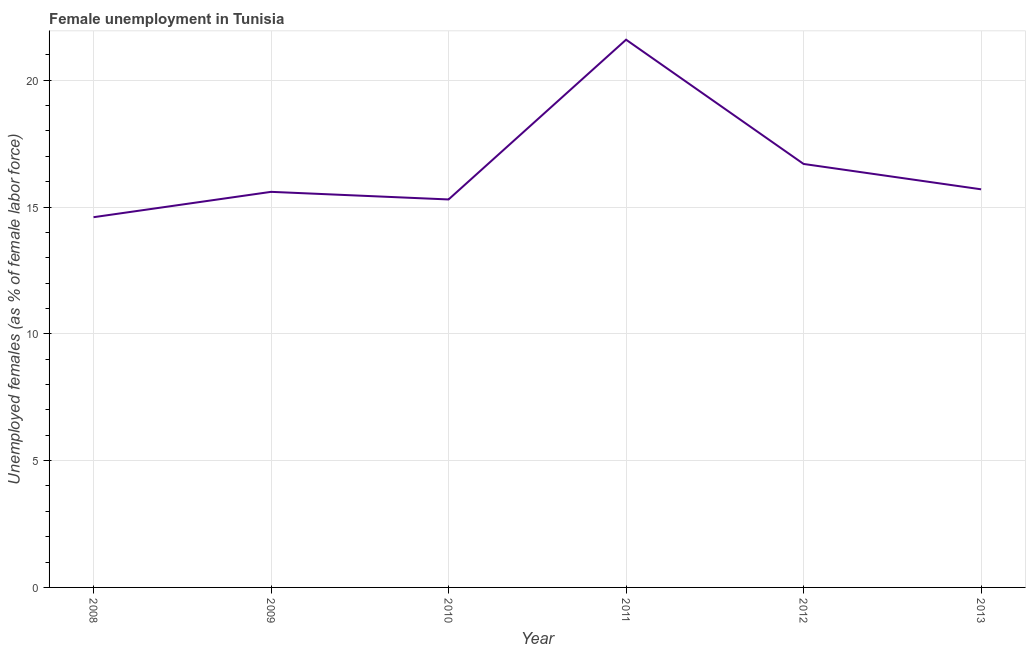What is the unemployed females population in 2013?
Ensure brevity in your answer.  15.7. Across all years, what is the maximum unemployed females population?
Provide a short and direct response. 21.6. Across all years, what is the minimum unemployed females population?
Your answer should be very brief. 14.6. In which year was the unemployed females population minimum?
Keep it short and to the point. 2008. What is the sum of the unemployed females population?
Make the answer very short. 99.5. What is the difference between the unemployed females population in 2008 and 2011?
Ensure brevity in your answer.  -7. What is the average unemployed females population per year?
Provide a short and direct response. 16.58. What is the median unemployed females population?
Ensure brevity in your answer.  15.65. In how many years, is the unemployed females population greater than 13 %?
Make the answer very short. 6. Do a majority of the years between 2009 and 2010 (inclusive) have unemployed females population greater than 20 %?
Ensure brevity in your answer.  No. What is the ratio of the unemployed females population in 2010 to that in 2011?
Provide a short and direct response. 0.71. Is the difference between the unemployed females population in 2008 and 2010 greater than the difference between any two years?
Your response must be concise. No. What is the difference between the highest and the second highest unemployed females population?
Provide a short and direct response. 4.9. What is the difference between the highest and the lowest unemployed females population?
Ensure brevity in your answer.  7. In how many years, is the unemployed females population greater than the average unemployed females population taken over all years?
Your answer should be very brief. 2. Does the unemployed females population monotonically increase over the years?
Make the answer very short. No. How many lines are there?
Provide a short and direct response. 1. How many years are there in the graph?
Keep it short and to the point. 6. Are the values on the major ticks of Y-axis written in scientific E-notation?
Your answer should be very brief. No. Does the graph contain any zero values?
Ensure brevity in your answer.  No. What is the title of the graph?
Provide a short and direct response. Female unemployment in Tunisia. What is the label or title of the Y-axis?
Offer a very short reply. Unemployed females (as % of female labor force). What is the Unemployed females (as % of female labor force) of 2008?
Your answer should be very brief. 14.6. What is the Unemployed females (as % of female labor force) in 2009?
Ensure brevity in your answer.  15.6. What is the Unemployed females (as % of female labor force) of 2010?
Provide a succinct answer. 15.3. What is the Unemployed females (as % of female labor force) in 2011?
Provide a short and direct response. 21.6. What is the Unemployed females (as % of female labor force) in 2012?
Provide a short and direct response. 16.7. What is the Unemployed females (as % of female labor force) in 2013?
Provide a short and direct response. 15.7. What is the difference between the Unemployed females (as % of female labor force) in 2008 and 2012?
Give a very brief answer. -2.1. What is the difference between the Unemployed females (as % of female labor force) in 2009 and 2010?
Ensure brevity in your answer.  0.3. What is the difference between the Unemployed females (as % of female labor force) in 2009 and 2011?
Provide a succinct answer. -6. What is the difference between the Unemployed females (as % of female labor force) in 2010 and 2012?
Your response must be concise. -1.4. What is the difference between the Unemployed females (as % of female labor force) in 2011 and 2012?
Your response must be concise. 4.9. What is the difference between the Unemployed females (as % of female labor force) in 2011 and 2013?
Your response must be concise. 5.9. What is the ratio of the Unemployed females (as % of female labor force) in 2008 to that in 2009?
Provide a short and direct response. 0.94. What is the ratio of the Unemployed females (as % of female labor force) in 2008 to that in 2010?
Ensure brevity in your answer.  0.95. What is the ratio of the Unemployed females (as % of female labor force) in 2008 to that in 2011?
Ensure brevity in your answer.  0.68. What is the ratio of the Unemployed females (as % of female labor force) in 2008 to that in 2012?
Your answer should be compact. 0.87. What is the ratio of the Unemployed females (as % of female labor force) in 2008 to that in 2013?
Your answer should be compact. 0.93. What is the ratio of the Unemployed females (as % of female labor force) in 2009 to that in 2011?
Offer a terse response. 0.72. What is the ratio of the Unemployed females (as % of female labor force) in 2009 to that in 2012?
Ensure brevity in your answer.  0.93. What is the ratio of the Unemployed females (as % of female labor force) in 2009 to that in 2013?
Keep it short and to the point. 0.99. What is the ratio of the Unemployed females (as % of female labor force) in 2010 to that in 2011?
Provide a succinct answer. 0.71. What is the ratio of the Unemployed females (as % of female labor force) in 2010 to that in 2012?
Give a very brief answer. 0.92. What is the ratio of the Unemployed females (as % of female labor force) in 2011 to that in 2012?
Your response must be concise. 1.29. What is the ratio of the Unemployed females (as % of female labor force) in 2011 to that in 2013?
Your response must be concise. 1.38. What is the ratio of the Unemployed females (as % of female labor force) in 2012 to that in 2013?
Your response must be concise. 1.06. 